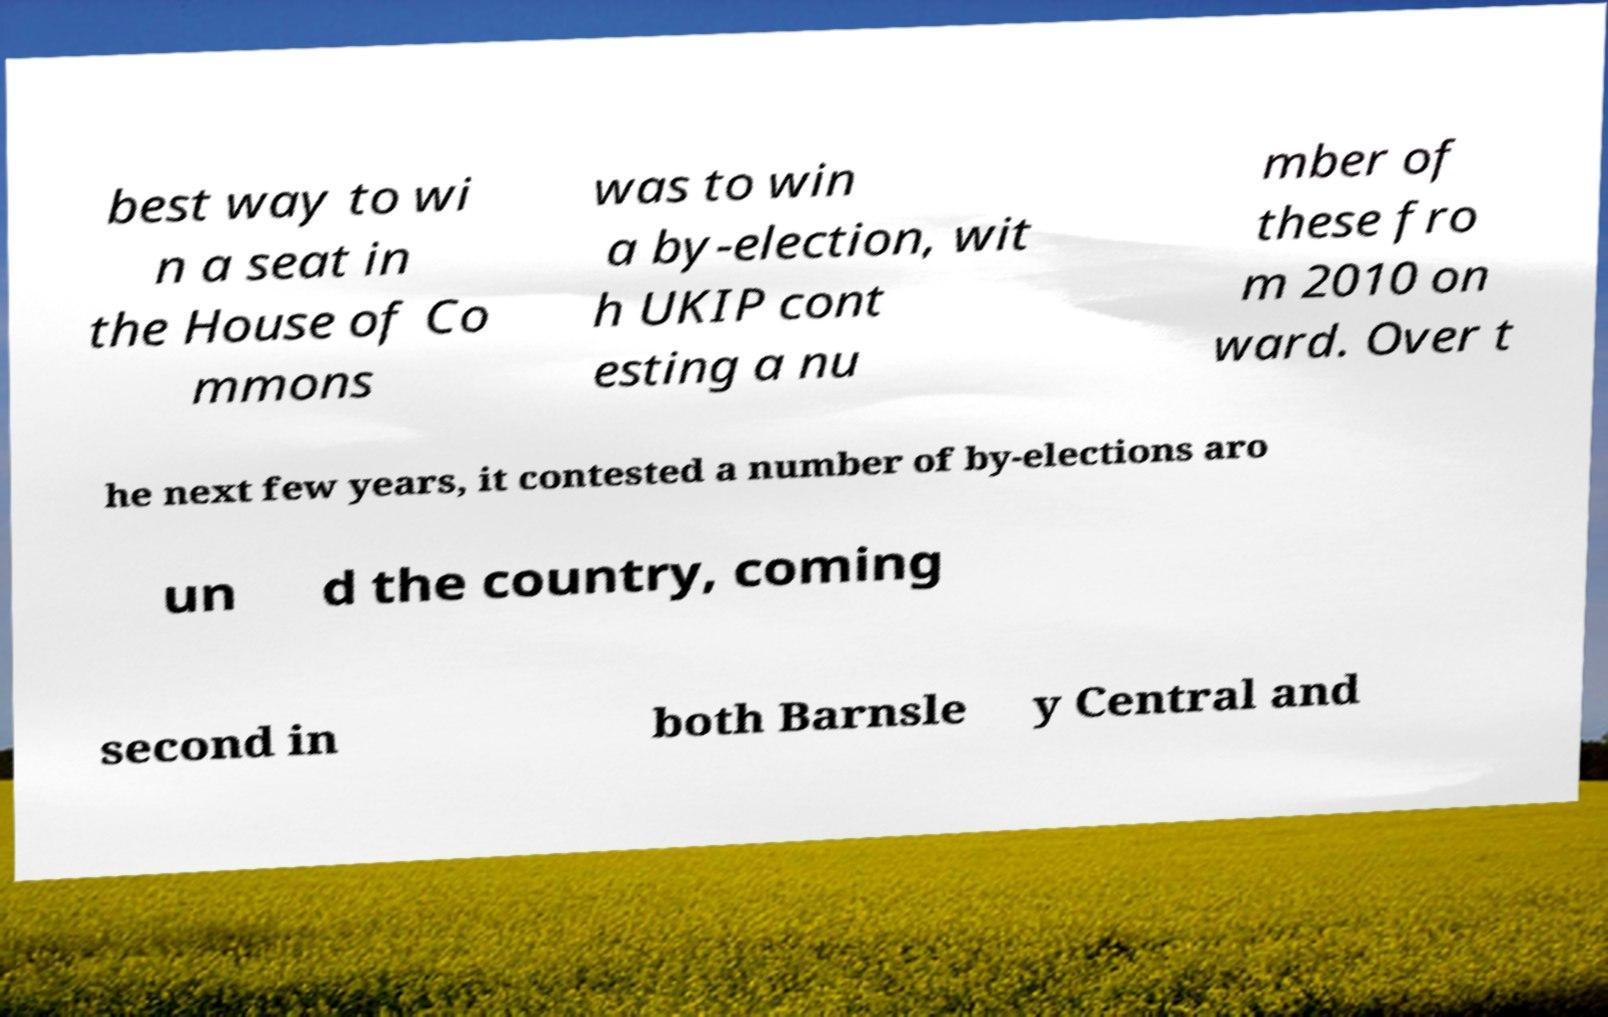I need the written content from this picture converted into text. Can you do that? best way to wi n a seat in the House of Co mmons was to win a by-election, wit h UKIP cont esting a nu mber of these fro m 2010 on ward. Over t he next few years, it contested a number of by-elections aro un d the country, coming second in both Barnsle y Central and 